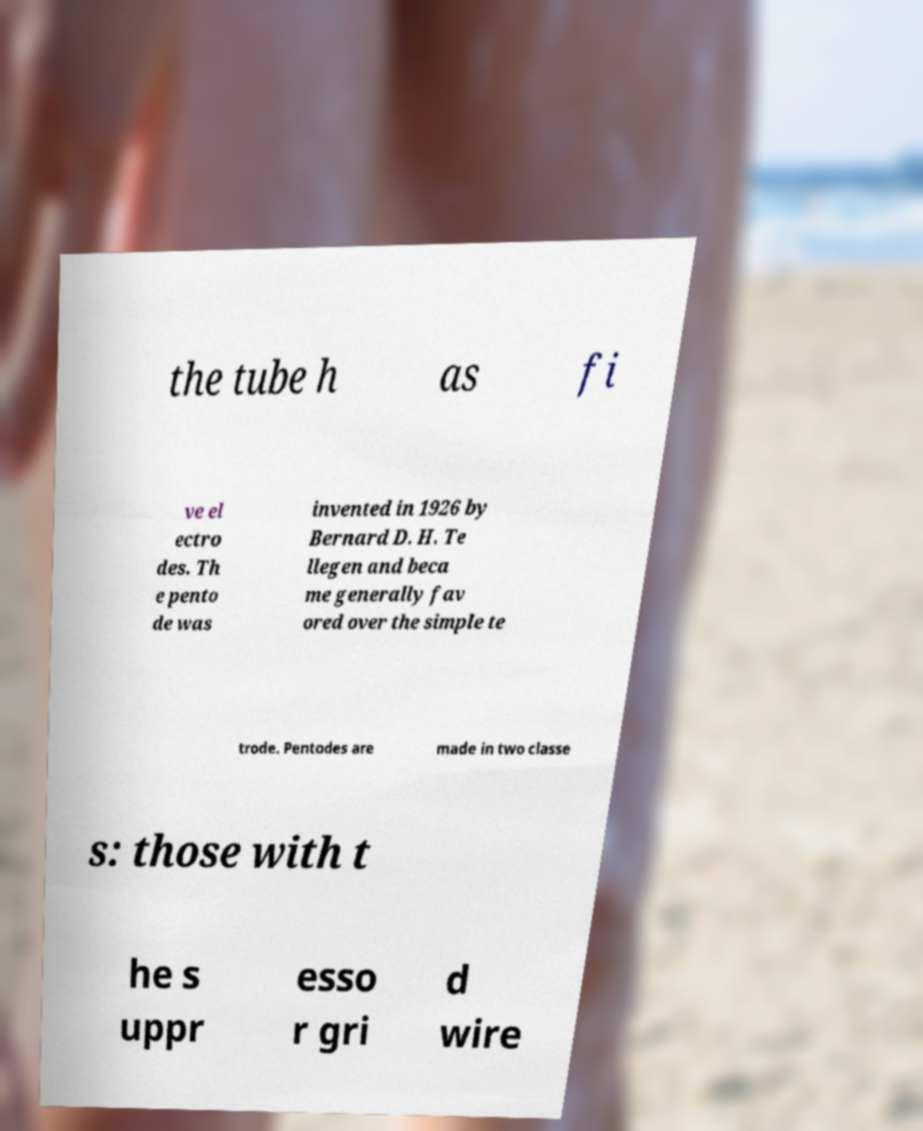Please read and relay the text visible in this image. What does it say? the tube h as fi ve el ectro des. Th e pento de was invented in 1926 by Bernard D. H. Te llegen and beca me generally fav ored over the simple te trode. Pentodes are made in two classe s: those with t he s uppr esso r gri d wire 